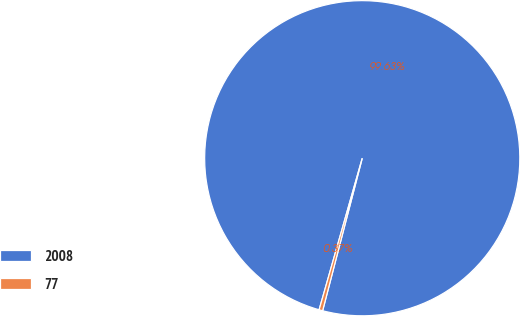<chart> <loc_0><loc_0><loc_500><loc_500><pie_chart><fcel>2008<fcel>77<nl><fcel>99.63%<fcel>0.37%<nl></chart> 